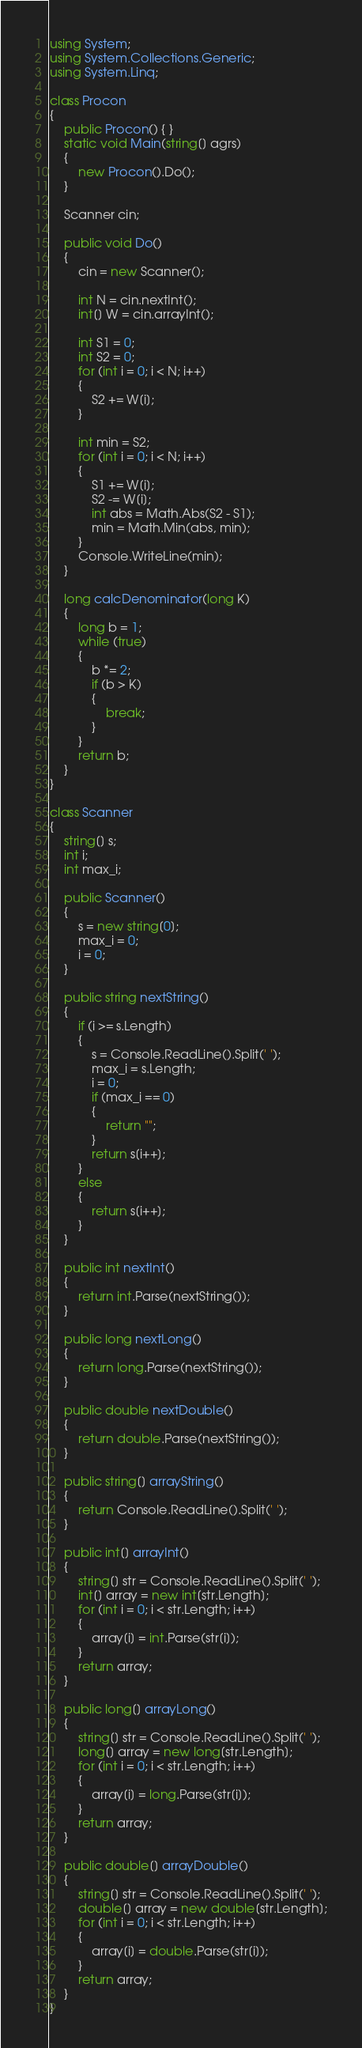Convert code to text. <code><loc_0><loc_0><loc_500><loc_500><_C#_>using System;
using System.Collections.Generic;
using System.Linq;

class Procon
{
    public Procon() { }
    static void Main(string[] agrs)
    {
        new Procon().Do();
    }

    Scanner cin;

    public void Do()
    {
        cin = new Scanner();

        int N = cin.nextInt();
        int[] W = cin.arrayInt();

        int S1 = 0;
        int S2 = 0;
        for (int i = 0; i < N; i++)
        {
            S2 += W[i];
        }

        int min = S2;
        for (int i = 0; i < N; i++)
        {
            S1 += W[i];
            S2 -= W[i];
            int abs = Math.Abs(S2 - S1);
            min = Math.Min(abs, min);
        }
        Console.WriteLine(min);
    }

    long calcDenominator(long K)
    {
        long b = 1;
        while (true)
        {
            b *= 2;
            if (b > K)
            {
                break;
            }
        }
        return b;
    }
}

class Scanner
{
    string[] s;
    int i;
    int max_i;

    public Scanner()
    {
        s = new string[0];
        max_i = 0;
        i = 0;
    }

    public string nextString()
    {
        if (i >= s.Length)
        {
            s = Console.ReadLine().Split(' ');
            max_i = s.Length;
            i = 0;
            if (max_i == 0)
            {
                return "";
            }
            return s[i++];
        }
        else
        {
            return s[i++];
        }
    }

    public int nextInt()
    {
        return int.Parse(nextString());
    }

    public long nextLong()
    {
        return long.Parse(nextString());
    }

    public double nextDouble()
    {
        return double.Parse(nextString());
    }

    public string[] arrayString()
    {
        return Console.ReadLine().Split(' ');
    }

    public int[] arrayInt()
    {
        string[] str = Console.ReadLine().Split(' ');
        int[] array = new int[str.Length];
        for (int i = 0; i < str.Length; i++)
        {
            array[i] = int.Parse(str[i]);
        }
        return array;
    }

    public long[] arrayLong()
    {
        string[] str = Console.ReadLine().Split(' ');
        long[] array = new long[str.Length];
        for (int i = 0; i < str.Length; i++)
        {
            array[i] = long.Parse(str[i]);
        }
        return array;
    }

    public double[] arrayDouble()
    {
        string[] str = Console.ReadLine().Split(' ');
        double[] array = new double[str.Length];
        for (int i = 0; i < str.Length; i++)
        {
            array[i] = double.Parse(str[i]);
        }
        return array;
    }
}
</code> 